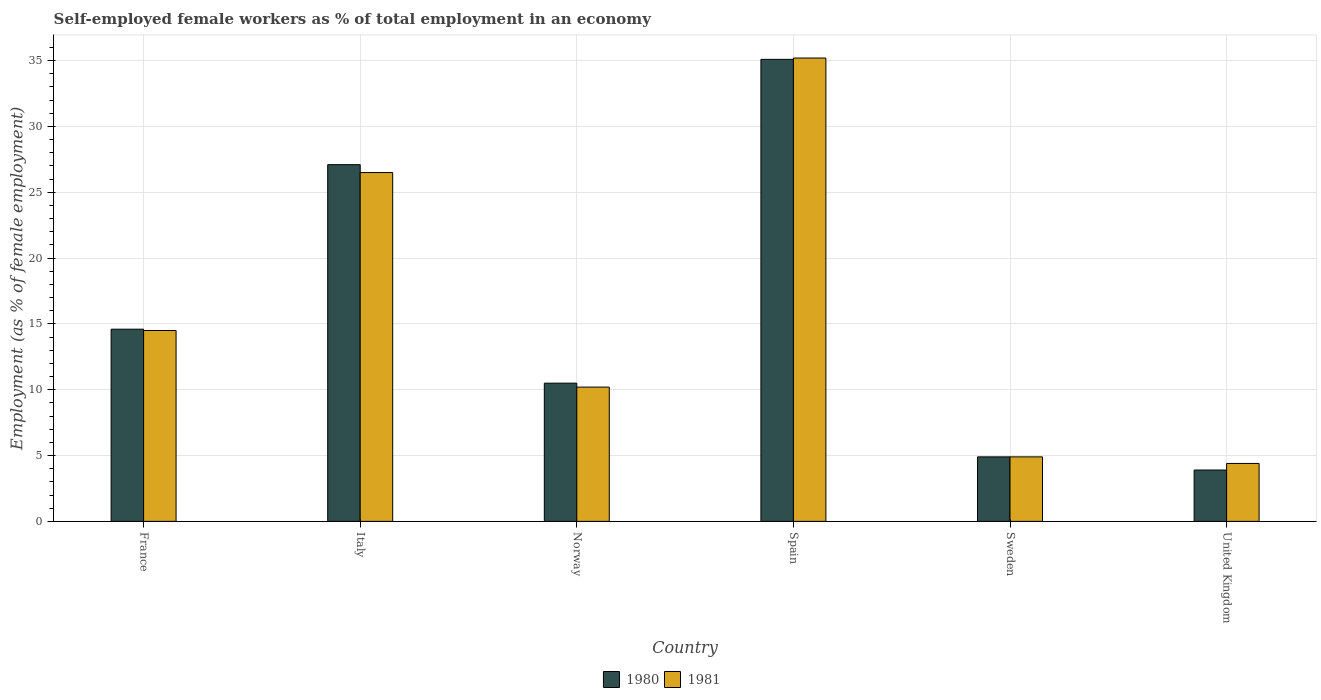How many different coloured bars are there?
Your answer should be compact. 2. Are the number of bars per tick equal to the number of legend labels?
Provide a succinct answer. Yes. How many bars are there on the 5th tick from the right?
Give a very brief answer. 2. What is the label of the 2nd group of bars from the left?
Your answer should be compact. Italy. Across all countries, what is the maximum percentage of self-employed female workers in 1981?
Keep it short and to the point. 35.2. Across all countries, what is the minimum percentage of self-employed female workers in 1980?
Keep it short and to the point. 3.9. What is the total percentage of self-employed female workers in 1980 in the graph?
Offer a terse response. 96.1. What is the difference between the percentage of self-employed female workers in 1981 in Italy and that in Norway?
Provide a short and direct response. 16.3. What is the difference between the percentage of self-employed female workers in 1980 in United Kingdom and the percentage of self-employed female workers in 1981 in Italy?
Offer a very short reply. -22.6. What is the average percentage of self-employed female workers in 1980 per country?
Your answer should be compact. 16.02. What is the difference between the percentage of self-employed female workers of/in 1980 and percentage of self-employed female workers of/in 1981 in Spain?
Give a very brief answer. -0.1. In how many countries, is the percentage of self-employed female workers in 1981 greater than 29 %?
Your answer should be very brief. 1. What is the ratio of the percentage of self-employed female workers in 1980 in Italy to that in United Kingdom?
Provide a succinct answer. 6.95. Is the difference between the percentage of self-employed female workers in 1980 in France and Norway greater than the difference between the percentage of self-employed female workers in 1981 in France and Norway?
Your response must be concise. No. What is the difference between the highest and the second highest percentage of self-employed female workers in 1981?
Your answer should be compact. -8.7. What is the difference between the highest and the lowest percentage of self-employed female workers in 1980?
Your answer should be very brief. 31.2. In how many countries, is the percentage of self-employed female workers in 1981 greater than the average percentage of self-employed female workers in 1981 taken over all countries?
Your answer should be compact. 2. Is the sum of the percentage of self-employed female workers in 1981 in Italy and United Kingdom greater than the maximum percentage of self-employed female workers in 1980 across all countries?
Your answer should be very brief. No. Are all the bars in the graph horizontal?
Offer a very short reply. No. How many countries are there in the graph?
Your answer should be very brief. 6. What is the difference between two consecutive major ticks on the Y-axis?
Give a very brief answer. 5. Are the values on the major ticks of Y-axis written in scientific E-notation?
Provide a short and direct response. No. Does the graph contain any zero values?
Provide a short and direct response. No. Does the graph contain grids?
Offer a terse response. Yes. What is the title of the graph?
Keep it short and to the point. Self-employed female workers as % of total employment in an economy. What is the label or title of the Y-axis?
Your answer should be very brief. Employment (as % of female employment). What is the Employment (as % of female employment) of 1980 in France?
Your response must be concise. 14.6. What is the Employment (as % of female employment) of 1980 in Italy?
Ensure brevity in your answer.  27.1. What is the Employment (as % of female employment) in 1981 in Italy?
Ensure brevity in your answer.  26.5. What is the Employment (as % of female employment) of 1981 in Norway?
Provide a short and direct response. 10.2. What is the Employment (as % of female employment) of 1980 in Spain?
Keep it short and to the point. 35.1. What is the Employment (as % of female employment) in 1981 in Spain?
Provide a succinct answer. 35.2. What is the Employment (as % of female employment) of 1980 in Sweden?
Provide a short and direct response. 4.9. What is the Employment (as % of female employment) of 1981 in Sweden?
Provide a succinct answer. 4.9. What is the Employment (as % of female employment) of 1980 in United Kingdom?
Ensure brevity in your answer.  3.9. What is the Employment (as % of female employment) in 1981 in United Kingdom?
Your response must be concise. 4.4. Across all countries, what is the maximum Employment (as % of female employment) in 1980?
Ensure brevity in your answer.  35.1. Across all countries, what is the maximum Employment (as % of female employment) in 1981?
Provide a succinct answer. 35.2. Across all countries, what is the minimum Employment (as % of female employment) in 1980?
Your response must be concise. 3.9. Across all countries, what is the minimum Employment (as % of female employment) of 1981?
Offer a terse response. 4.4. What is the total Employment (as % of female employment) in 1980 in the graph?
Ensure brevity in your answer.  96.1. What is the total Employment (as % of female employment) in 1981 in the graph?
Your response must be concise. 95.7. What is the difference between the Employment (as % of female employment) in 1981 in France and that in Italy?
Your answer should be compact. -12. What is the difference between the Employment (as % of female employment) of 1980 in France and that in Spain?
Give a very brief answer. -20.5. What is the difference between the Employment (as % of female employment) of 1981 in France and that in Spain?
Offer a very short reply. -20.7. What is the difference between the Employment (as % of female employment) in 1981 in France and that in United Kingdom?
Provide a succinct answer. 10.1. What is the difference between the Employment (as % of female employment) of 1980 in Italy and that in Norway?
Your answer should be very brief. 16.6. What is the difference between the Employment (as % of female employment) of 1981 in Italy and that in Norway?
Ensure brevity in your answer.  16.3. What is the difference between the Employment (as % of female employment) of 1980 in Italy and that in Spain?
Your answer should be very brief. -8. What is the difference between the Employment (as % of female employment) in 1980 in Italy and that in Sweden?
Your answer should be compact. 22.2. What is the difference between the Employment (as % of female employment) in 1981 in Italy and that in Sweden?
Offer a terse response. 21.6. What is the difference between the Employment (as % of female employment) of 1980 in Italy and that in United Kingdom?
Your answer should be very brief. 23.2. What is the difference between the Employment (as % of female employment) in 1981 in Italy and that in United Kingdom?
Make the answer very short. 22.1. What is the difference between the Employment (as % of female employment) of 1980 in Norway and that in Spain?
Your answer should be very brief. -24.6. What is the difference between the Employment (as % of female employment) in 1980 in Norway and that in Sweden?
Provide a succinct answer. 5.6. What is the difference between the Employment (as % of female employment) of 1980 in Norway and that in United Kingdom?
Provide a succinct answer. 6.6. What is the difference between the Employment (as % of female employment) in 1980 in Spain and that in Sweden?
Ensure brevity in your answer.  30.2. What is the difference between the Employment (as % of female employment) in 1981 in Spain and that in Sweden?
Provide a short and direct response. 30.3. What is the difference between the Employment (as % of female employment) of 1980 in Spain and that in United Kingdom?
Provide a short and direct response. 31.2. What is the difference between the Employment (as % of female employment) of 1981 in Spain and that in United Kingdom?
Your response must be concise. 30.8. What is the difference between the Employment (as % of female employment) in 1981 in Sweden and that in United Kingdom?
Make the answer very short. 0.5. What is the difference between the Employment (as % of female employment) in 1980 in France and the Employment (as % of female employment) in 1981 in Italy?
Keep it short and to the point. -11.9. What is the difference between the Employment (as % of female employment) of 1980 in France and the Employment (as % of female employment) of 1981 in Spain?
Provide a succinct answer. -20.6. What is the difference between the Employment (as % of female employment) in 1980 in Italy and the Employment (as % of female employment) in 1981 in Norway?
Offer a very short reply. 16.9. What is the difference between the Employment (as % of female employment) of 1980 in Italy and the Employment (as % of female employment) of 1981 in United Kingdom?
Offer a terse response. 22.7. What is the difference between the Employment (as % of female employment) of 1980 in Norway and the Employment (as % of female employment) of 1981 in Spain?
Your answer should be compact. -24.7. What is the difference between the Employment (as % of female employment) of 1980 in Norway and the Employment (as % of female employment) of 1981 in Sweden?
Provide a succinct answer. 5.6. What is the difference between the Employment (as % of female employment) in 1980 in Norway and the Employment (as % of female employment) in 1981 in United Kingdom?
Offer a very short reply. 6.1. What is the difference between the Employment (as % of female employment) of 1980 in Spain and the Employment (as % of female employment) of 1981 in Sweden?
Make the answer very short. 30.2. What is the difference between the Employment (as % of female employment) of 1980 in Spain and the Employment (as % of female employment) of 1981 in United Kingdom?
Provide a succinct answer. 30.7. What is the average Employment (as % of female employment) of 1980 per country?
Your answer should be compact. 16.02. What is the average Employment (as % of female employment) in 1981 per country?
Ensure brevity in your answer.  15.95. What is the difference between the Employment (as % of female employment) in 1980 and Employment (as % of female employment) in 1981 in France?
Your response must be concise. 0.1. What is the difference between the Employment (as % of female employment) in 1980 and Employment (as % of female employment) in 1981 in Italy?
Keep it short and to the point. 0.6. What is the difference between the Employment (as % of female employment) of 1980 and Employment (as % of female employment) of 1981 in Norway?
Provide a short and direct response. 0.3. What is the difference between the Employment (as % of female employment) of 1980 and Employment (as % of female employment) of 1981 in Spain?
Your answer should be compact. -0.1. What is the difference between the Employment (as % of female employment) of 1980 and Employment (as % of female employment) of 1981 in United Kingdom?
Keep it short and to the point. -0.5. What is the ratio of the Employment (as % of female employment) of 1980 in France to that in Italy?
Offer a very short reply. 0.54. What is the ratio of the Employment (as % of female employment) of 1981 in France to that in Italy?
Your answer should be compact. 0.55. What is the ratio of the Employment (as % of female employment) in 1980 in France to that in Norway?
Offer a terse response. 1.39. What is the ratio of the Employment (as % of female employment) of 1981 in France to that in Norway?
Give a very brief answer. 1.42. What is the ratio of the Employment (as % of female employment) of 1980 in France to that in Spain?
Provide a succinct answer. 0.42. What is the ratio of the Employment (as % of female employment) of 1981 in France to that in Spain?
Ensure brevity in your answer.  0.41. What is the ratio of the Employment (as % of female employment) of 1980 in France to that in Sweden?
Your response must be concise. 2.98. What is the ratio of the Employment (as % of female employment) in 1981 in France to that in Sweden?
Provide a short and direct response. 2.96. What is the ratio of the Employment (as % of female employment) of 1980 in France to that in United Kingdom?
Give a very brief answer. 3.74. What is the ratio of the Employment (as % of female employment) in 1981 in France to that in United Kingdom?
Make the answer very short. 3.3. What is the ratio of the Employment (as % of female employment) in 1980 in Italy to that in Norway?
Make the answer very short. 2.58. What is the ratio of the Employment (as % of female employment) in 1981 in Italy to that in Norway?
Your response must be concise. 2.6. What is the ratio of the Employment (as % of female employment) of 1980 in Italy to that in Spain?
Your answer should be compact. 0.77. What is the ratio of the Employment (as % of female employment) of 1981 in Italy to that in Spain?
Your response must be concise. 0.75. What is the ratio of the Employment (as % of female employment) in 1980 in Italy to that in Sweden?
Your answer should be compact. 5.53. What is the ratio of the Employment (as % of female employment) in 1981 in Italy to that in Sweden?
Make the answer very short. 5.41. What is the ratio of the Employment (as % of female employment) in 1980 in Italy to that in United Kingdom?
Offer a very short reply. 6.95. What is the ratio of the Employment (as % of female employment) in 1981 in Italy to that in United Kingdom?
Keep it short and to the point. 6.02. What is the ratio of the Employment (as % of female employment) of 1980 in Norway to that in Spain?
Provide a succinct answer. 0.3. What is the ratio of the Employment (as % of female employment) of 1981 in Norway to that in Spain?
Keep it short and to the point. 0.29. What is the ratio of the Employment (as % of female employment) in 1980 in Norway to that in Sweden?
Provide a succinct answer. 2.14. What is the ratio of the Employment (as % of female employment) of 1981 in Norway to that in Sweden?
Your response must be concise. 2.08. What is the ratio of the Employment (as % of female employment) of 1980 in Norway to that in United Kingdom?
Your answer should be compact. 2.69. What is the ratio of the Employment (as % of female employment) of 1981 in Norway to that in United Kingdom?
Offer a very short reply. 2.32. What is the ratio of the Employment (as % of female employment) in 1980 in Spain to that in Sweden?
Provide a succinct answer. 7.16. What is the ratio of the Employment (as % of female employment) in 1981 in Spain to that in Sweden?
Give a very brief answer. 7.18. What is the ratio of the Employment (as % of female employment) in 1980 in Spain to that in United Kingdom?
Keep it short and to the point. 9. What is the ratio of the Employment (as % of female employment) in 1980 in Sweden to that in United Kingdom?
Your answer should be compact. 1.26. What is the ratio of the Employment (as % of female employment) of 1981 in Sweden to that in United Kingdom?
Offer a terse response. 1.11. What is the difference between the highest and the second highest Employment (as % of female employment) of 1981?
Your answer should be very brief. 8.7. What is the difference between the highest and the lowest Employment (as % of female employment) in 1980?
Offer a terse response. 31.2. What is the difference between the highest and the lowest Employment (as % of female employment) in 1981?
Offer a very short reply. 30.8. 